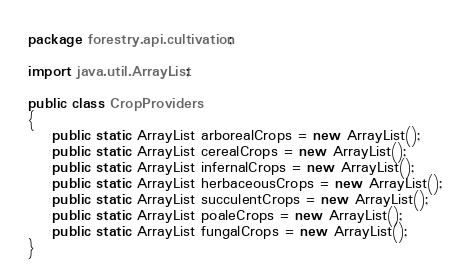Convert code to text. <code><loc_0><loc_0><loc_500><loc_500><_Java_>package forestry.api.cultivation;

import java.util.ArrayList;

public class CropProviders
{
    public static ArrayList arborealCrops = new ArrayList();
    public static ArrayList cerealCrops = new ArrayList();
    public static ArrayList infernalCrops = new ArrayList();
    public static ArrayList herbaceousCrops = new ArrayList();
    public static ArrayList succulentCrops = new ArrayList();
    public static ArrayList poaleCrops = new ArrayList();
    public static ArrayList fungalCrops = new ArrayList();
}
</code> 